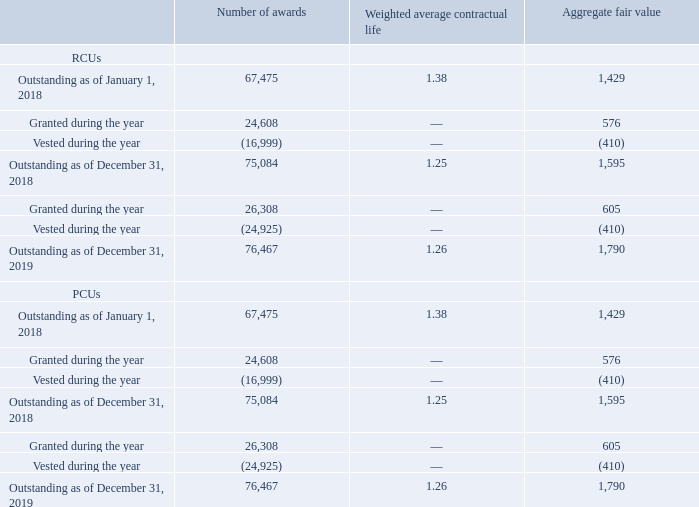GasLog Ltd. and its Subsidiaries
Notes to the consolidated financial statements (Continued)
For the years ended December 31, 2017, 2018 and 2019
(All amounts expressed in thousands of U.S. Dollars, except share and per share data)
22. Share-Based Compensation (Continued)
Movement in RCUs and PCUs
The summary of RCUs and PCUs is presented below:
The total expense recognized in respect of share-based compensation for the year ended December 31, 2019 was $5,107 (December 31, 2018: $5,216 and December 31, 2017: $4,565). The total accrued cash distribution as of December 31, 2019 is $1,176 (December 31, 2018: $1,265).
What are the two components of the share based compensation? Rcus, pcus. What was the number of awards of RCUs granted during the year in 2018?
Answer scale should be: thousand. 24,608. What was the number of awards of PCUs granted during the year in 2018?
Answer scale should be: thousand. 24,608. In which year was the total expense recognized in respect of share-based compensation the highest? $5,216 > $5,107 > $4,565
Answer: 2018. What was the change in total expense recognized from 2017 to 2018?
Answer scale should be: thousand. $5,216 - $4,565 
Answer: 651. What was the percentage change in total accrued cash distribution from 2018 to 2019?
Answer scale should be: percent. ($1,176- $1,265)/$1,265 
Answer: -7.04. 